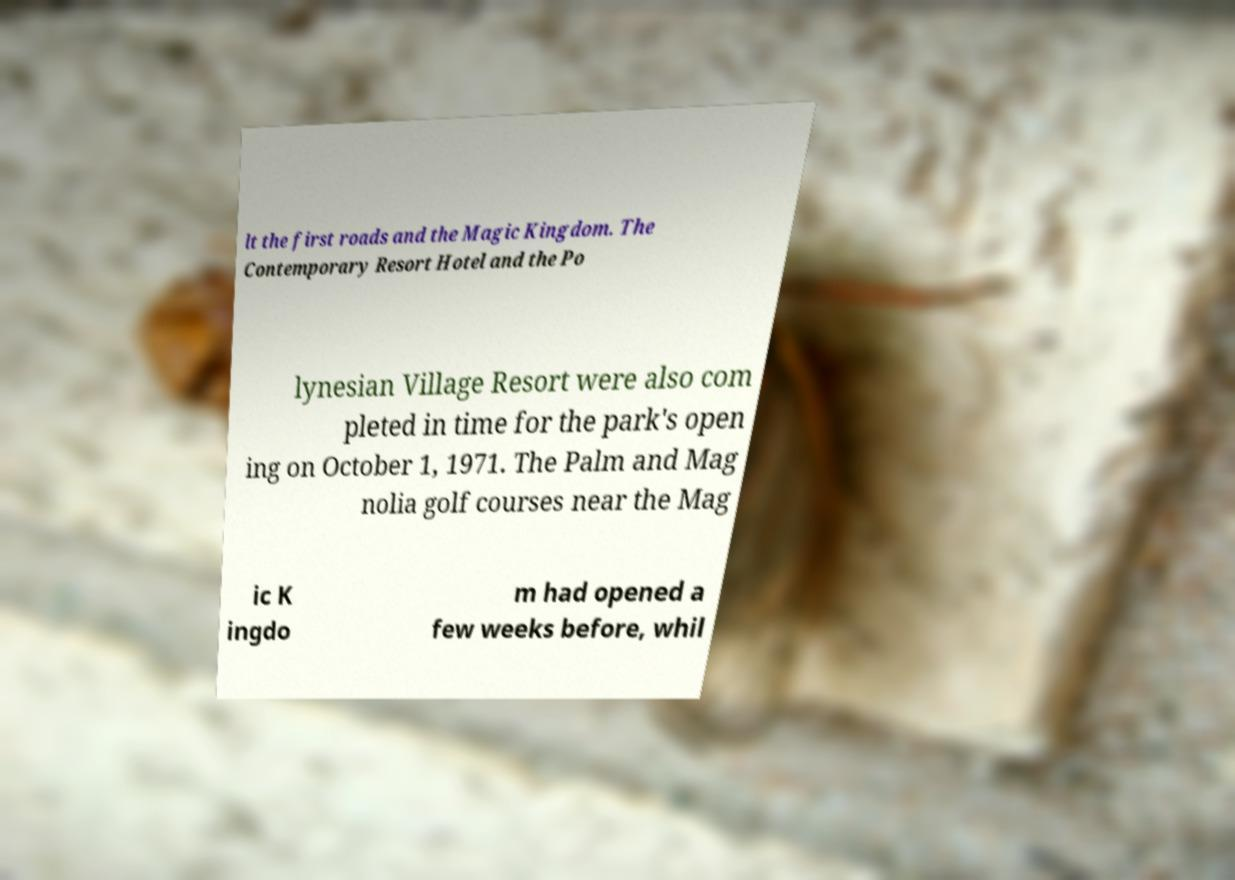Could you assist in decoding the text presented in this image and type it out clearly? lt the first roads and the Magic Kingdom. The Contemporary Resort Hotel and the Po lynesian Village Resort were also com pleted in time for the park's open ing on October 1, 1971. The Palm and Mag nolia golf courses near the Mag ic K ingdo m had opened a few weeks before, whil 